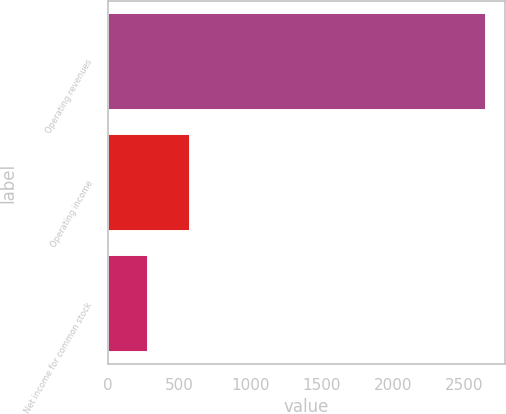<chart> <loc_0><loc_0><loc_500><loc_500><bar_chart><fcel>Operating revenues<fcel>Operating income<fcel>Net income for common stock<nl><fcel>2655<fcel>579<fcel>282<nl></chart> 